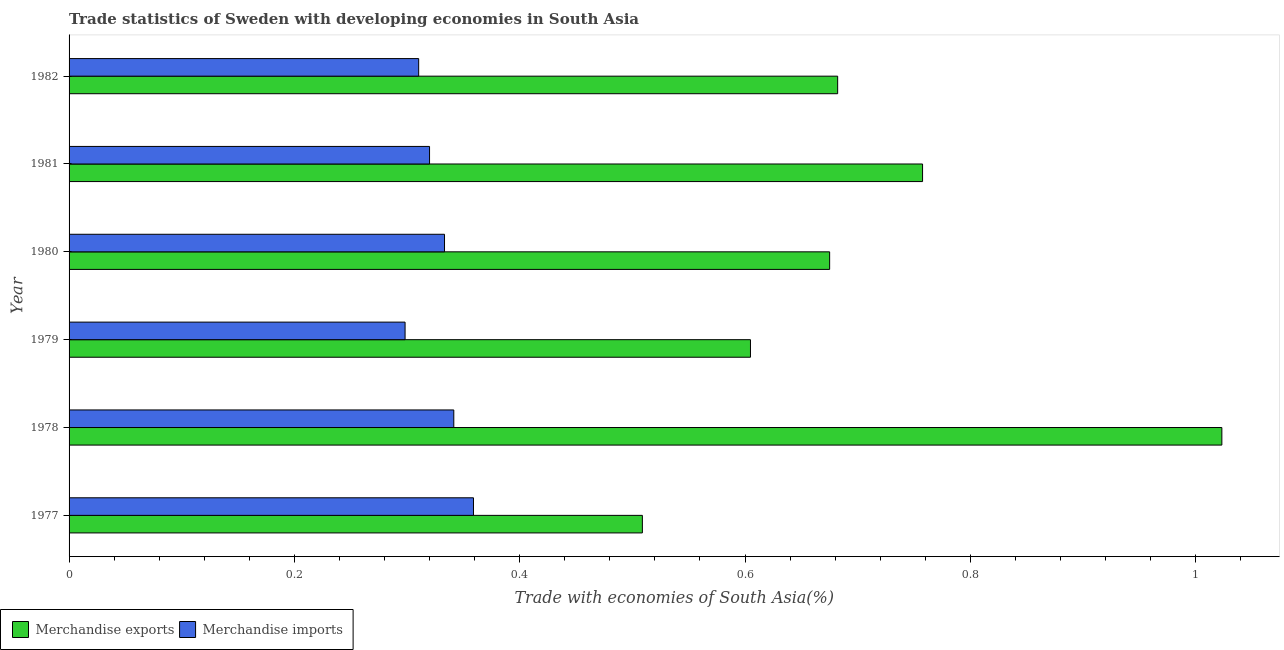How many different coloured bars are there?
Give a very brief answer. 2. How many groups of bars are there?
Provide a succinct answer. 6. How many bars are there on the 2nd tick from the top?
Provide a short and direct response. 2. What is the merchandise imports in 1979?
Make the answer very short. 0.3. Across all years, what is the maximum merchandise exports?
Provide a succinct answer. 1.02. Across all years, what is the minimum merchandise imports?
Provide a short and direct response. 0.3. In which year was the merchandise imports maximum?
Your response must be concise. 1977. In which year was the merchandise exports minimum?
Give a very brief answer. 1977. What is the total merchandise imports in the graph?
Give a very brief answer. 1.96. What is the difference between the merchandise exports in 1979 and that in 1982?
Provide a short and direct response. -0.08. What is the difference between the merchandise imports in 1977 and the merchandise exports in 1982?
Offer a very short reply. -0.32. What is the average merchandise exports per year?
Give a very brief answer. 0.71. In the year 1982, what is the difference between the merchandise imports and merchandise exports?
Ensure brevity in your answer.  -0.37. In how many years, is the merchandise imports greater than 0.04 %?
Provide a succinct answer. 6. What is the ratio of the merchandise imports in 1979 to that in 1982?
Keep it short and to the point. 0.96. Is the difference between the merchandise imports in 1979 and 1982 greater than the difference between the merchandise exports in 1979 and 1982?
Offer a very short reply. Yes. What is the difference between the highest and the second highest merchandise exports?
Give a very brief answer. 0.27. What is the difference between the highest and the lowest merchandise imports?
Your answer should be compact. 0.06. In how many years, is the merchandise imports greater than the average merchandise imports taken over all years?
Offer a terse response. 3. Are the values on the major ticks of X-axis written in scientific E-notation?
Your response must be concise. No. Does the graph contain any zero values?
Give a very brief answer. No. How many legend labels are there?
Offer a very short reply. 2. How are the legend labels stacked?
Provide a succinct answer. Horizontal. What is the title of the graph?
Provide a short and direct response. Trade statistics of Sweden with developing economies in South Asia. Does "Age 65(male)" appear as one of the legend labels in the graph?
Make the answer very short. No. What is the label or title of the X-axis?
Your response must be concise. Trade with economies of South Asia(%). What is the Trade with economies of South Asia(%) in Merchandise exports in 1977?
Provide a short and direct response. 0.51. What is the Trade with economies of South Asia(%) in Merchandise imports in 1977?
Your answer should be compact. 0.36. What is the Trade with economies of South Asia(%) in Merchandise exports in 1978?
Your answer should be very brief. 1.02. What is the Trade with economies of South Asia(%) of Merchandise imports in 1978?
Provide a succinct answer. 0.34. What is the Trade with economies of South Asia(%) of Merchandise exports in 1979?
Your answer should be very brief. 0.6. What is the Trade with economies of South Asia(%) of Merchandise imports in 1979?
Your response must be concise. 0.3. What is the Trade with economies of South Asia(%) in Merchandise exports in 1980?
Your answer should be very brief. 0.68. What is the Trade with economies of South Asia(%) of Merchandise imports in 1980?
Your response must be concise. 0.33. What is the Trade with economies of South Asia(%) of Merchandise exports in 1981?
Offer a terse response. 0.76. What is the Trade with economies of South Asia(%) of Merchandise imports in 1981?
Keep it short and to the point. 0.32. What is the Trade with economies of South Asia(%) of Merchandise exports in 1982?
Keep it short and to the point. 0.68. What is the Trade with economies of South Asia(%) in Merchandise imports in 1982?
Keep it short and to the point. 0.31. Across all years, what is the maximum Trade with economies of South Asia(%) in Merchandise exports?
Provide a short and direct response. 1.02. Across all years, what is the maximum Trade with economies of South Asia(%) in Merchandise imports?
Ensure brevity in your answer.  0.36. Across all years, what is the minimum Trade with economies of South Asia(%) in Merchandise exports?
Provide a short and direct response. 0.51. Across all years, what is the minimum Trade with economies of South Asia(%) of Merchandise imports?
Offer a very short reply. 0.3. What is the total Trade with economies of South Asia(%) in Merchandise exports in the graph?
Your answer should be compact. 4.25. What is the total Trade with economies of South Asia(%) in Merchandise imports in the graph?
Provide a succinct answer. 1.96. What is the difference between the Trade with economies of South Asia(%) of Merchandise exports in 1977 and that in 1978?
Ensure brevity in your answer.  -0.51. What is the difference between the Trade with economies of South Asia(%) of Merchandise imports in 1977 and that in 1978?
Your answer should be very brief. 0.02. What is the difference between the Trade with economies of South Asia(%) of Merchandise exports in 1977 and that in 1979?
Your answer should be very brief. -0.1. What is the difference between the Trade with economies of South Asia(%) in Merchandise imports in 1977 and that in 1979?
Your answer should be very brief. 0.06. What is the difference between the Trade with economies of South Asia(%) of Merchandise exports in 1977 and that in 1980?
Ensure brevity in your answer.  -0.17. What is the difference between the Trade with economies of South Asia(%) in Merchandise imports in 1977 and that in 1980?
Your answer should be very brief. 0.03. What is the difference between the Trade with economies of South Asia(%) of Merchandise exports in 1977 and that in 1981?
Give a very brief answer. -0.25. What is the difference between the Trade with economies of South Asia(%) of Merchandise imports in 1977 and that in 1981?
Your response must be concise. 0.04. What is the difference between the Trade with economies of South Asia(%) of Merchandise exports in 1977 and that in 1982?
Give a very brief answer. -0.17. What is the difference between the Trade with economies of South Asia(%) of Merchandise imports in 1977 and that in 1982?
Provide a succinct answer. 0.05. What is the difference between the Trade with economies of South Asia(%) of Merchandise exports in 1978 and that in 1979?
Your response must be concise. 0.42. What is the difference between the Trade with economies of South Asia(%) in Merchandise imports in 1978 and that in 1979?
Provide a succinct answer. 0.04. What is the difference between the Trade with economies of South Asia(%) in Merchandise exports in 1978 and that in 1980?
Your answer should be compact. 0.35. What is the difference between the Trade with economies of South Asia(%) in Merchandise imports in 1978 and that in 1980?
Keep it short and to the point. 0.01. What is the difference between the Trade with economies of South Asia(%) in Merchandise exports in 1978 and that in 1981?
Offer a very short reply. 0.27. What is the difference between the Trade with economies of South Asia(%) of Merchandise imports in 1978 and that in 1981?
Keep it short and to the point. 0.02. What is the difference between the Trade with economies of South Asia(%) in Merchandise exports in 1978 and that in 1982?
Keep it short and to the point. 0.34. What is the difference between the Trade with economies of South Asia(%) in Merchandise imports in 1978 and that in 1982?
Provide a short and direct response. 0.03. What is the difference between the Trade with economies of South Asia(%) of Merchandise exports in 1979 and that in 1980?
Ensure brevity in your answer.  -0.07. What is the difference between the Trade with economies of South Asia(%) of Merchandise imports in 1979 and that in 1980?
Provide a short and direct response. -0.04. What is the difference between the Trade with economies of South Asia(%) of Merchandise exports in 1979 and that in 1981?
Offer a very short reply. -0.15. What is the difference between the Trade with economies of South Asia(%) of Merchandise imports in 1979 and that in 1981?
Give a very brief answer. -0.02. What is the difference between the Trade with economies of South Asia(%) of Merchandise exports in 1979 and that in 1982?
Provide a short and direct response. -0.08. What is the difference between the Trade with economies of South Asia(%) of Merchandise imports in 1979 and that in 1982?
Offer a very short reply. -0.01. What is the difference between the Trade with economies of South Asia(%) in Merchandise exports in 1980 and that in 1981?
Your answer should be compact. -0.08. What is the difference between the Trade with economies of South Asia(%) of Merchandise imports in 1980 and that in 1981?
Ensure brevity in your answer.  0.01. What is the difference between the Trade with economies of South Asia(%) of Merchandise exports in 1980 and that in 1982?
Make the answer very short. -0.01. What is the difference between the Trade with economies of South Asia(%) of Merchandise imports in 1980 and that in 1982?
Offer a very short reply. 0.02. What is the difference between the Trade with economies of South Asia(%) of Merchandise exports in 1981 and that in 1982?
Ensure brevity in your answer.  0.08. What is the difference between the Trade with economies of South Asia(%) in Merchandise imports in 1981 and that in 1982?
Ensure brevity in your answer.  0.01. What is the difference between the Trade with economies of South Asia(%) of Merchandise exports in 1977 and the Trade with economies of South Asia(%) of Merchandise imports in 1978?
Offer a terse response. 0.17. What is the difference between the Trade with economies of South Asia(%) of Merchandise exports in 1977 and the Trade with economies of South Asia(%) of Merchandise imports in 1979?
Your answer should be very brief. 0.21. What is the difference between the Trade with economies of South Asia(%) in Merchandise exports in 1977 and the Trade with economies of South Asia(%) in Merchandise imports in 1980?
Offer a terse response. 0.18. What is the difference between the Trade with economies of South Asia(%) of Merchandise exports in 1977 and the Trade with economies of South Asia(%) of Merchandise imports in 1981?
Ensure brevity in your answer.  0.19. What is the difference between the Trade with economies of South Asia(%) of Merchandise exports in 1977 and the Trade with economies of South Asia(%) of Merchandise imports in 1982?
Make the answer very short. 0.2. What is the difference between the Trade with economies of South Asia(%) of Merchandise exports in 1978 and the Trade with economies of South Asia(%) of Merchandise imports in 1979?
Provide a succinct answer. 0.72. What is the difference between the Trade with economies of South Asia(%) of Merchandise exports in 1978 and the Trade with economies of South Asia(%) of Merchandise imports in 1980?
Keep it short and to the point. 0.69. What is the difference between the Trade with economies of South Asia(%) of Merchandise exports in 1978 and the Trade with economies of South Asia(%) of Merchandise imports in 1981?
Ensure brevity in your answer.  0.7. What is the difference between the Trade with economies of South Asia(%) of Merchandise exports in 1978 and the Trade with economies of South Asia(%) of Merchandise imports in 1982?
Your answer should be very brief. 0.71. What is the difference between the Trade with economies of South Asia(%) in Merchandise exports in 1979 and the Trade with economies of South Asia(%) in Merchandise imports in 1980?
Offer a very short reply. 0.27. What is the difference between the Trade with economies of South Asia(%) of Merchandise exports in 1979 and the Trade with economies of South Asia(%) of Merchandise imports in 1981?
Your response must be concise. 0.28. What is the difference between the Trade with economies of South Asia(%) of Merchandise exports in 1979 and the Trade with economies of South Asia(%) of Merchandise imports in 1982?
Keep it short and to the point. 0.29. What is the difference between the Trade with economies of South Asia(%) in Merchandise exports in 1980 and the Trade with economies of South Asia(%) in Merchandise imports in 1981?
Ensure brevity in your answer.  0.36. What is the difference between the Trade with economies of South Asia(%) in Merchandise exports in 1980 and the Trade with economies of South Asia(%) in Merchandise imports in 1982?
Your answer should be compact. 0.36. What is the difference between the Trade with economies of South Asia(%) in Merchandise exports in 1981 and the Trade with economies of South Asia(%) in Merchandise imports in 1982?
Provide a succinct answer. 0.45. What is the average Trade with economies of South Asia(%) in Merchandise exports per year?
Your response must be concise. 0.71. What is the average Trade with economies of South Asia(%) of Merchandise imports per year?
Your answer should be very brief. 0.33. In the year 1977, what is the difference between the Trade with economies of South Asia(%) of Merchandise exports and Trade with economies of South Asia(%) of Merchandise imports?
Keep it short and to the point. 0.15. In the year 1978, what is the difference between the Trade with economies of South Asia(%) of Merchandise exports and Trade with economies of South Asia(%) of Merchandise imports?
Offer a terse response. 0.68. In the year 1979, what is the difference between the Trade with economies of South Asia(%) in Merchandise exports and Trade with economies of South Asia(%) in Merchandise imports?
Offer a very short reply. 0.31. In the year 1980, what is the difference between the Trade with economies of South Asia(%) in Merchandise exports and Trade with economies of South Asia(%) in Merchandise imports?
Give a very brief answer. 0.34. In the year 1981, what is the difference between the Trade with economies of South Asia(%) of Merchandise exports and Trade with economies of South Asia(%) of Merchandise imports?
Your answer should be compact. 0.44. In the year 1982, what is the difference between the Trade with economies of South Asia(%) of Merchandise exports and Trade with economies of South Asia(%) of Merchandise imports?
Ensure brevity in your answer.  0.37. What is the ratio of the Trade with economies of South Asia(%) of Merchandise exports in 1977 to that in 1978?
Offer a very short reply. 0.5. What is the ratio of the Trade with economies of South Asia(%) of Merchandise imports in 1977 to that in 1978?
Provide a succinct answer. 1.05. What is the ratio of the Trade with economies of South Asia(%) in Merchandise exports in 1977 to that in 1979?
Your answer should be compact. 0.84. What is the ratio of the Trade with economies of South Asia(%) in Merchandise imports in 1977 to that in 1979?
Your answer should be compact. 1.2. What is the ratio of the Trade with economies of South Asia(%) of Merchandise exports in 1977 to that in 1980?
Offer a terse response. 0.75. What is the ratio of the Trade with economies of South Asia(%) in Merchandise imports in 1977 to that in 1980?
Keep it short and to the point. 1.08. What is the ratio of the Trade with economies of South Asia(%) in Merchandise exports in 1977 to that in 1981?
Your answer should be very brief. 0.67. What is the ratio of the Trade with economies of South Asia(%) of Merchandise imports in 1977 to that in 1981?
Offer a very short reply. 1.12. What is the ratio of the Trade with economies of South Asia(%) of Merchandise exports in 1977 to that in 1982?
Offer a very short reply. 0.75. What is the ratio of the Trade with economies of South Asia(%) of Merchandise imports in 1977 to that in 1982?
Give a very brief answer. 1.16. What is the ratio of the Trade with economies of South Asia(%) in Merchandise exports in 1978 to that in 1979?
Keep it short and to the point. 1.69. What is the ratio of the Trade with economies of South Asia(%) in Merchandise imports in 1978 to that in 1979?
Your answer should be very brief. 1.15. What is the ratio of the Trade with economies of South Asia(%) of Merchandise exports in 1978 to that in 1980?
Offer a very short reply. 1.52. What is the ratio of the Trade with economies of South Asia(%) of Merchandise imports in 1978 to that in 1980?
Your answer should be very brief. 1.02. What is the ratio of the Trade with economies of South Asia(%) in Merchandise exports in 1978 to that in 1981?
Give a very brief answer. 1.35. What is the ratio of the Trade with economies of South Asia(%) of Merchandise imports in 1978 to that in 1981?
Offer a very short reply. 1.07. What is the ratio of the Trade with economies of South Asia(%) of Merchandise exports in 1978 to that in 1982?
Your answer should be compact. 1.5. What is the ratio of the Trade with economies of South Asia(%) of Merchandise imports in 1978 to that in 1982?
Your answer should be compact. 1.1. What is the ratio of the Trade with economies of South Asia(%) of Merchandise exports in 1979 to that in 1980?
Provide a short and direct response. 0.9. What is the ratio of the Trade with economies of South Asia(%) of Merchandise imports in 1979 to that in 1980?
Ensure brevity in your answer.  0.89. What is the ratio of the Trade with economies of South Asia(%) in Merchandise exports in 1979 to that in 1981?
Keep it short and to the point. 0.8. What is the ratio of the Trade with economies of South Asia(%) in Merchandise imports in 1979 to that in 1981?
Keep it short and to the point. 0.93. What is the ratio of the Trade with economies of South Asia(%) in Merchandise exports in 1979 to that in 1982?
Provide a short and direct response. 0.89. What is the ratio of the Trade with economies of South Asia(%) in Merchandise imports in 1979 to that in 1982?
Make the answer very short. 0.96. What is the ratio of the Trade with economies of South Asia(%) in Merchandise exports in 1980 to that in 1981?
Offer a very short reply. 0.89. What is the ratio of the Trade with economies of South Asia(%) in Merchandise imports in 1980 to that in 1981?
Offer a terse response. 1.04. What is the ratio of the Trade with economies of South Asia(%) of Merchandise exports in 1980 to that in 1982?
Provide a short and direct response. 0.99. What is the ratio of the Trade with economies of South Asia(%) in Merchandise imports in 1980 to that in 1982?
Your answer should be very brief. 1.07. What is the ratio of the Trade with economies of South Asia(%) in Merchandise exports in 1981 to that in 1982?
Make the answer very short. 1.11. What is the ratio of the Trade with economies of South Asia(%) in Merchandise imports in 1981 to that in 1982?
Your answer should be compact. 1.03. What is the difference between the highest and the second highest Trade with economies of South Asia(%) in Merchandise exports?
Keep it short and to the point. 0.27. What is the difference between the highest and the second highest Trade with economies of South Asia(%) in Merchandise imports?
Provide a succinct answer. 0.02. What is the difference between the highest and the lowest Trade with economies of South Asia(%) in Merchandise exports?
Offer a terse response. 0.51. What is the difference between the highest and the lowest Trade with economies of South Asia(%) of Merchandise imports?
Your response must be concise. 0.06. 